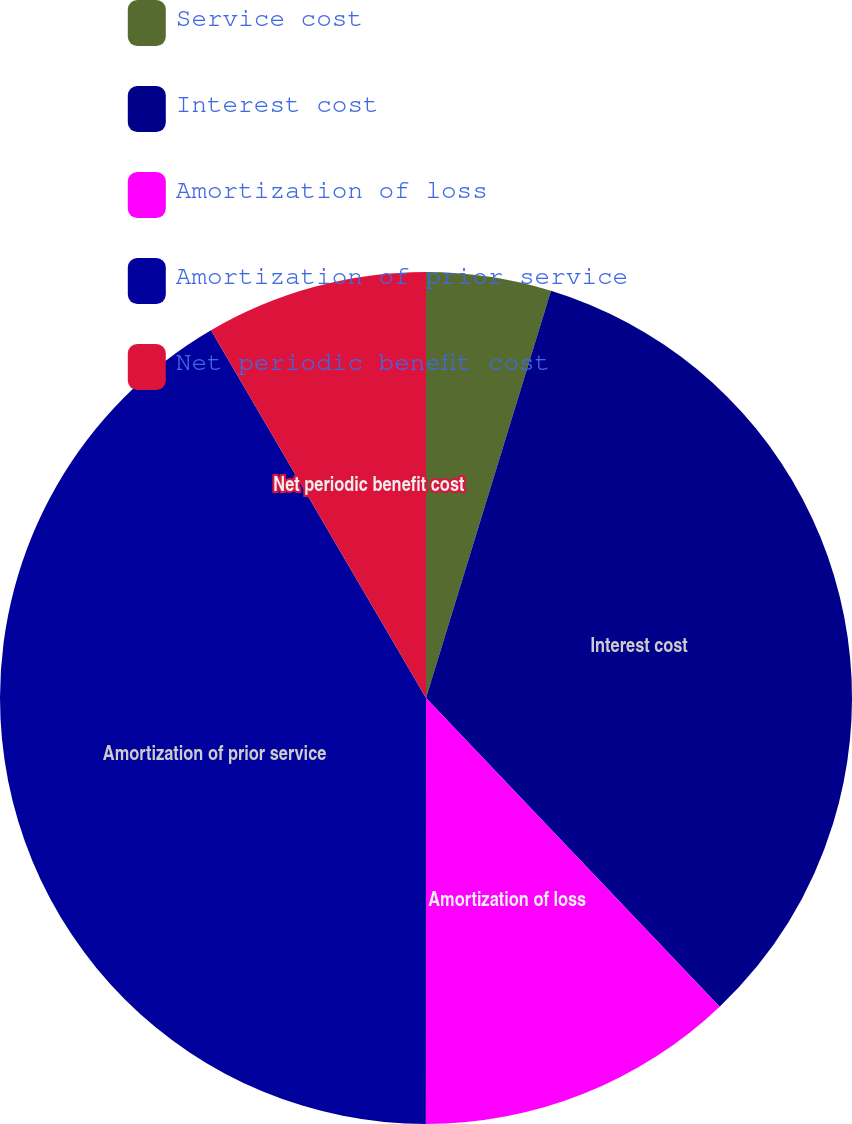<chart> <loc_0><loc_0><loc_500><loc_500><pie_chart><fcel>Service cost<fcel>Interest cost<fcel>Amortization of loss<fcel>Amortization of prior service<fcel>Net periodic benefit cost<nl><fcel>4.74%<fcel>33.16%<fcel>12.11%<fcel>41.58%<fcel>8.42%<nl></chart> 